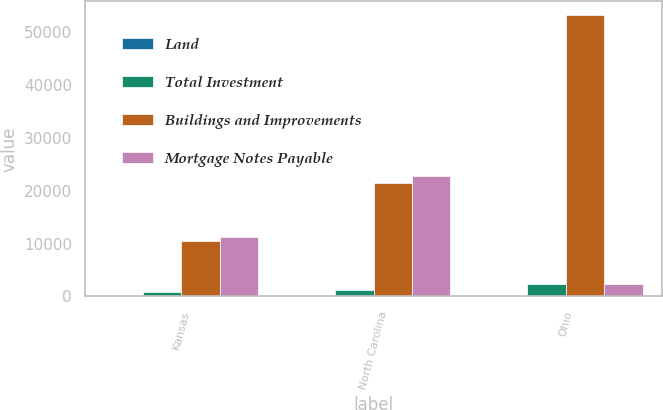Convert chart. <chart><loc_0><loc_0><loc_500><loc_500><stacked_bar_chart><ecel><fcel>Kansas<fcel>North Carolina<fcel>Ohio<nl><fcel>Land<fcel>3<fcel>6<fcel>12<nl><fcel>Total Investment<fcel>788<fcel>1298<fcel>2365<nl><fcel>Buildings and Improvements<fcel>10548<fcel>21446<fcel>53220<nl><fcel>Mortgage Notes Payable<fcel>11336<fcel>22744<fcel>2365<nl></chart> 